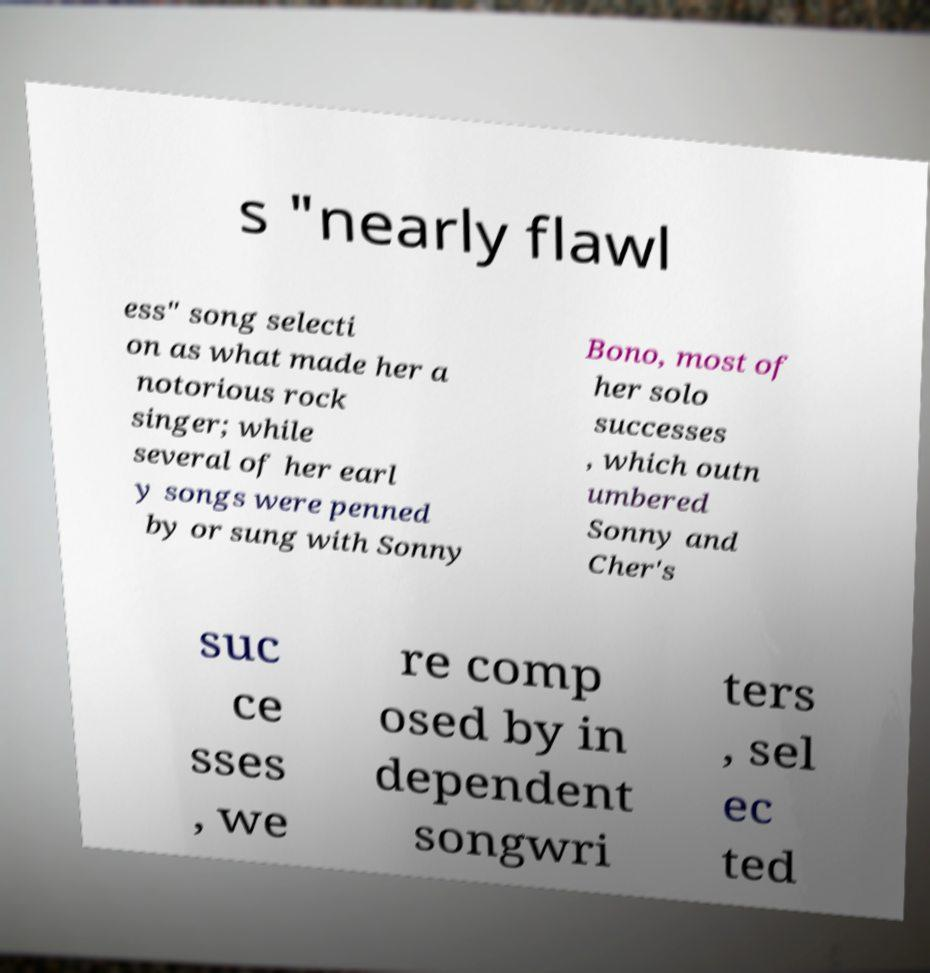What messages or text are displayed in this image? I need them in a readable, typed format. s "nearly flawl ess" song selecti on as what made her a notorious rock singer; while several of her earl y songs were penned by or sung with Sonny Bono, most of her solo successes , which outn umbered Sonny and Cher's suc ce sses , we re comp osed by in dependent songwri ters , sel ec ted 